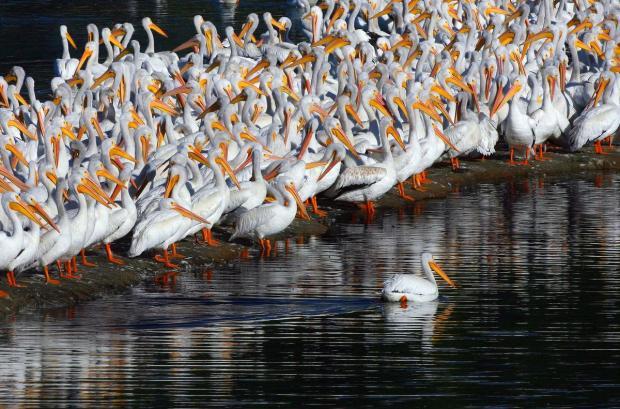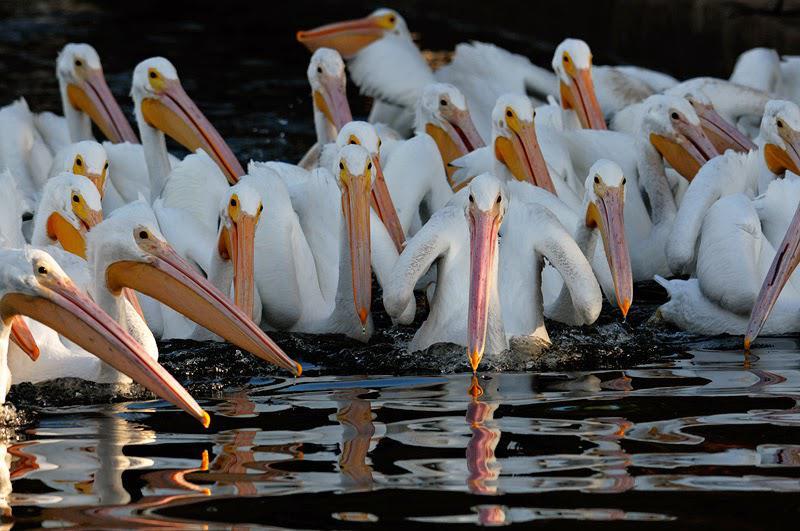The first image is the image on the left, the second image is the image on the right. Given the left and right images, does the statement "All of the birds are in or near the water." hold true? Answer yes or no. Yes. 